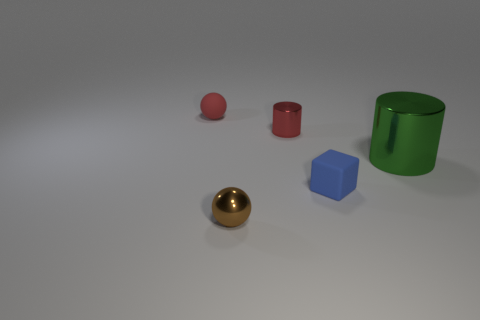Add 4 small purple matte blocks. How many objects exist? 9 Subtract all balls. How many objects are left? 3 Subtract all large objects. Subtract all tiny red matte objects. How many objects are left? 3 Add 2 small rubber balls. How many small rubber balls are left? 3 Add 5 big brown cylinders. How many big brown cylinders exist? 5 Subtract 0 blue balls. How many objects are left? 5 